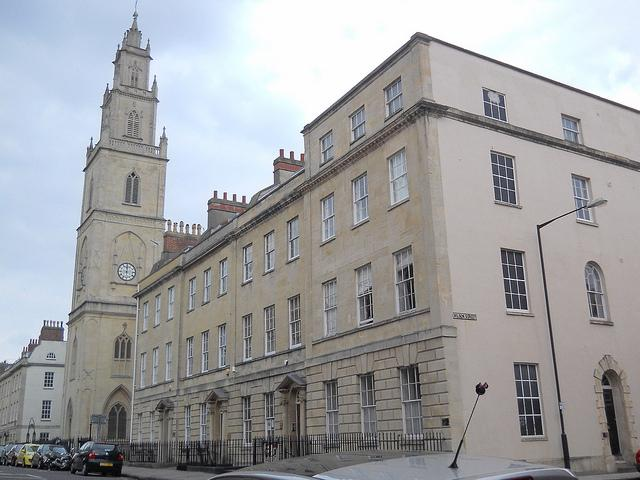What color are the chimney pieces on the top of the long rectangular house? red 